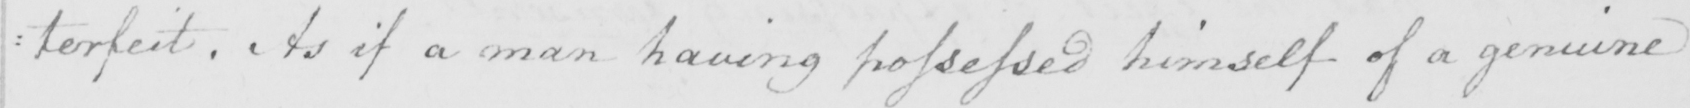Can you read and transcribe this handwriting? : terfeit . As if a man having possessed himself of a genuine 